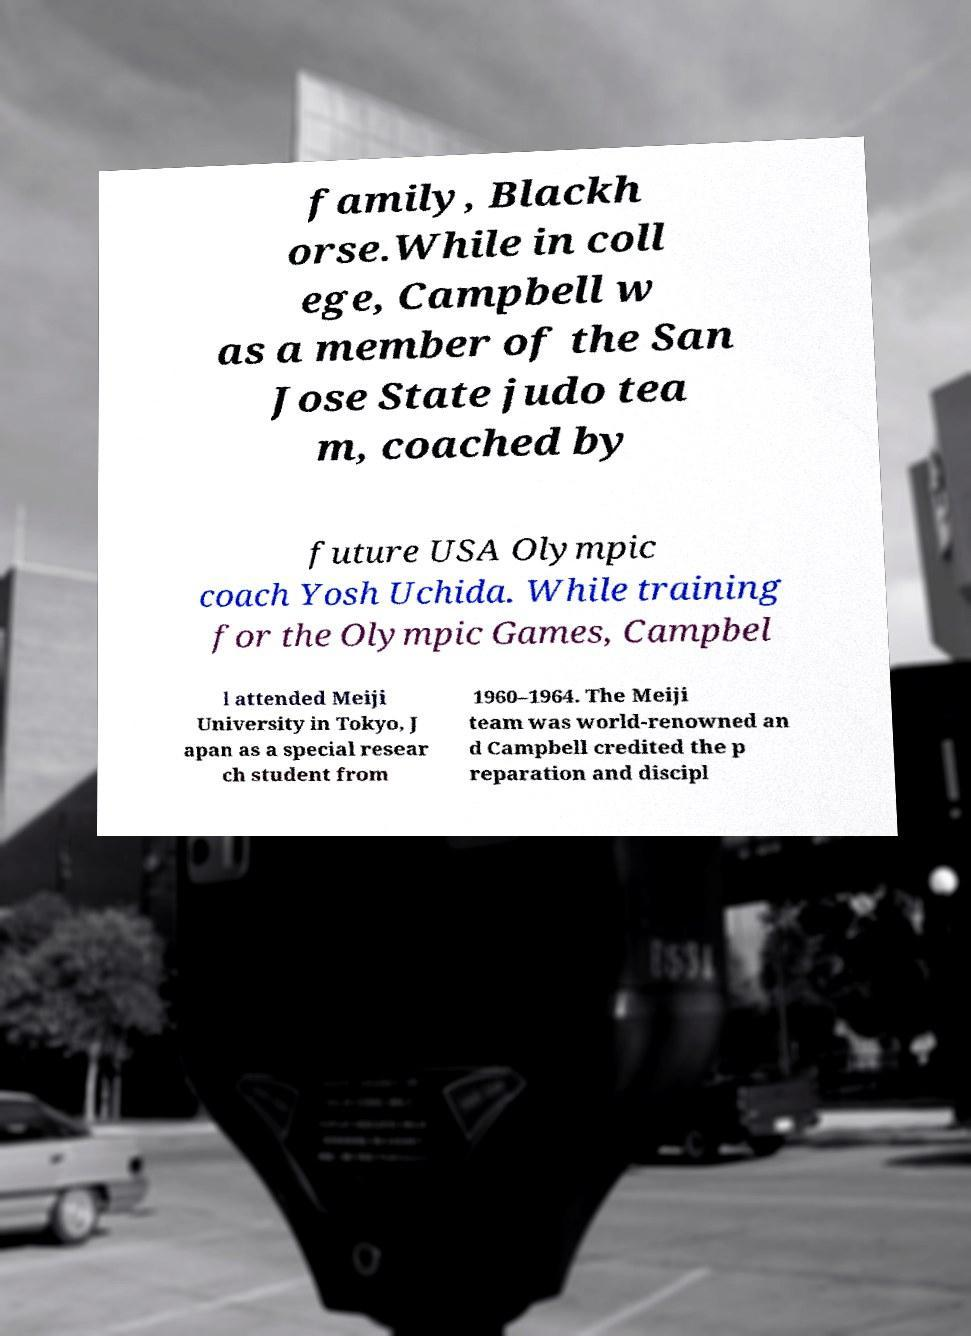Please read and relay the text visible in this image. What does it say? family, Blackh orse.While in coll ege, Campbell w as a member of the San Jose State judo tea m, coached by future USA Olympic coach Yosh Uchida. While training for the Olympic Games, Campbel l attended Meiji University in Tokyo, J apan as a special resear ch student from 1960–1964. The Meiji team was world-renowned an d Campbell credited the p reparation and discipl 